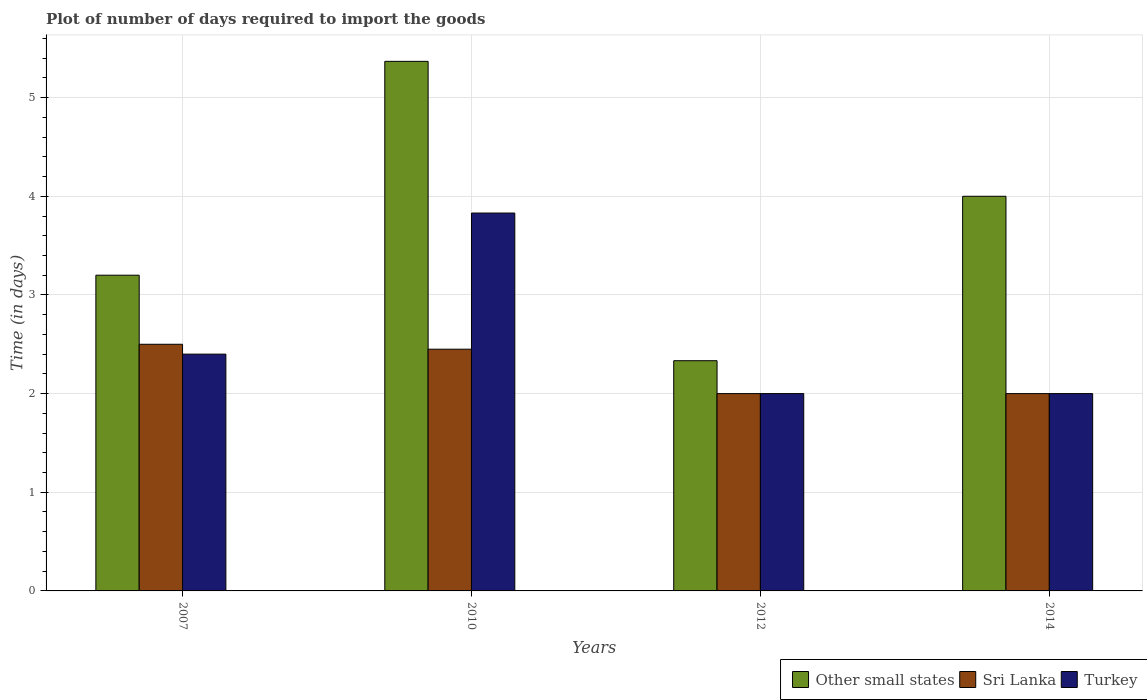How many different coloured bars are there?
Provide a succinct answer. 3. Are the number of bars per tick equal to the number of legend labels?
Give a very brief answer. Yes. How many bars are there on the 3rd tick from the left?
Provide a succinct answer. 3. How many bars are there on the 2nd tick from the right?
Offer a very short reply. 3. What is the label of the 3rd group of bars from the left?
Provide a succinct answer. 2012. In how many cases, is the number of bars for a given year not equal to the number of legend labels?
Ensure brevity in your answer.  0. Across all years, what is the maximum time required to import goods in Turkey?
Ensure brevity in your answer.  3.83. Across all years, what is the minimum time required to import goods in Sri Lanka?
Your response must be concise. 2. In which year was the time required to import goods in Turkey minimum?
Offer a very short reply. 2012. What is the total time required to import goods in Turkey in the graph?
Provide a succinct answer. 10.23. What is the difference between the time required to import goods in Other small states in 2007 and that in 2014?
Your answer should be compact. -0.8. What is the difference between the time required to import goods in Sri Lanka in 2014 and the time required to import goods in Other small states in 2012?
Your response must be concise. -0.33. What is the average time required to import goods in Turkey per year?
Provide a short and direct response. 2.56. In the year 2012, what is the difference between the time required to import goods in Turkey and time required to import goods in Other small states?
Your answer should be very brief. -0.33. In how many years, is the time required to import goods in Sri Lanka greater than 3 days?
Make the answer very short. 0. What is the ratio of the time required to import goods in Other small states in 2010 to that in 2014?
Offer a very short reply. 1.34. Is the difference between the time required to import goods in Turkey in 2010 and 2012 greater than the difference between the time required to import goods in Other small states in 2010 and 2012?
Your answer should be very brief. No. What is the difference between the highest and the second highest time required to import goods in Sri Lanka?
Your answer should be compact. 0.05. What does the 1st bar from the left in 2010 represents?
Give a very brief answer. Other small states. What does the 1st bar from the right in 2007 represents?
Ensure brevity in your answer.  Turkey. How many bars are there?
Give a very brief answer. 12. Are all the bars in the graph horizontal?
Provide a short and direct response. No. How many years are there in the graph?
Your answer should be compact. 4. Are the values on the major ticks of Y-axis written in scientific E-notation?
Your answer should be very brief. No. Does the graph contain grids?
Your answer should be compact. Yes. Where does the legend appear in the graph?
Keep it short and to the point. Bottom right. What is the title of the graph?
Give a very brief answer. Plot of number of days required to import the goods. Does "Mauritania" appear as one of the legend labels in the graph?
Keep it short and to the point. No. What is the label or title of the Y-axis?
Offer a very short reply. Time (in days). What is the Time (in days) in Sri Lanka in 2007?
Provide a succinct answer. 2.5. What is the Time (in days) in Other small states in 2010?
Provide a succinct answer. 5.37. What is the Time (in days) in Sri Lanka in 2010?
Give a very brief answer. 2.45. What is the Time (in days) of Turkey in 2010?
Offer a terse response. 3.83. What is the Time (in days) in Other small states in 2012?
Your answer should be compact. 2.33. What is the Time (in days) of Sri Lanka in 2012?
Make the answer very short. 2. What is the Time (in days) of Turkey in 2012?
Offer a terse response. 2. What is the Time (in days) of Sri Lanka in 2014?
Make the answer very short. 2. Across all years, what is the maximum Time (in days) of Other small states?
Your response must be concise. 5.37. Across all years, what is the maximum Time (in days) in Sri Lanka?
Provide a short and direct response. 2.5. Across all years, what is the maximum Time (in days) of Turkey?
Offer a very short reply. 3.83. Across all years, what is the minimum Time (in days) of Other small states?
Keep it short and to the point. 2.33. Across all years, what is the minimum Time (in days) in Turkey?
Offer a terse response. 2. What is the total Time (in days) of Other small states in the graph?
Offer a very short reply. 14.9. What is the total Time (in days) of Sri Lanka in the graph?
Ensure brevity in your answer.  8.95. What is the total Time (in days) in Turkey in the graph?
Provide a succinct answer. 10.23. What is the difference between the Time (in days) in Other small states in 2007 and that in 2010?
Offer a very short reply. -2.17. What is the difference between the Time (in days) in Turkey in 2007 and that in 2010?
Give a very brief answer. -1.43. What is the difference between the Time (in days) in Other small states in 2007 and that in 2012?
Provide a succinct answer. 0.87. What is the difference between the Time (in days) in Sri Lanka in 2007 and that in 2012?
Your answer should be compact. 0.5. What is the difference between the Time (in days) of Turkey in 2007 and that in 2012?
Ensure brevity in your answer.  0.4. What is the difference between the Time (in days) in Other small states in 2007 and that in 2014?
Offer a terse response. -0.8. What is the difference between the Time (in days) in Sri Lanka in 2007 and that in 2014?
Your answer should be compact. 0.5. What is the difference between the Time (in days) of Turkey in 2007 and that in 2014?
Your answer should be compact. 0.4. What is the difference between the Time (in days) in Other small states in 2010 and that in 2012?
Give a very brief answer. 3.03. What is the difference between the Time (in days) of Sri Lanka in 2010 and that in 2012?
Make the answer very short. 0.45. What is the difference between the Time (in days) in Turkey in 2010 and that in 2012?
Your response must be concise. 1.83. What is the difference between the Time (in days) in Other small states in 2010 and that in 2014?
Give a very brief answer. 1.37. What is the difference between the Time (in days) of Sri Lanka in 2010 and that in 2014?
Your answer should be compact. 0.45. What is the difference between the Time (in days) of Turkey in 2010 and that in 2014?
Make the answer very short. 1.83. What is the difference between the Time (in days) in Other small states in 2012 and that in 2014?
Your answer should be compact. -1.67. What is the difference between the Time (in days) of Sri Lanka in 2012 and that in 2014?
Your response must be concise. 0. What is the difference between the Time (in days) of Other small states in 2007 and the Time (in days) of Turkey in 2010?
Offer a terse response. -0.63. What is the difference between the Time (in days) of Sri Lanka in 2007 and the Time (in days) of Turkey in 2010?
Your answer should be compact. -1.33. What is the difference between the Time (in days) of Other small states in 2007 and the Time (in days) of Sri Lanka in 2012?
Your response must be concise. 1.2. What is the difference between the Time (in days) in Sri Lanka in 2007 and the Time (in days) in Turkey in 2012?
Keep it short and to the point. 0.5. What is the difference between the Time (in days) of Other small states in 2007 and the Time (in days) of Sri Lanka in 2014?
Your response must be concise. 1.2. What is the difference between the Time (in days) of Sri Lanka in 2007 and the Time (in days) of Turkey in 2014?
Your response must be concise. 0.5. What is the difference between the Time (in days) of Other small states in 2010 and the Time (in days) of Sri Lanka in 2012?
Make the answer very short. 3.37. What is the difference between the Time (in days) of Other small states in 2010 and the Time (in days) of Turkey in 2012?
Make the answer very short. 3.37. What is the difference between the Time (in days) in Sri Lanka in 2010 and the Time (in days) in Turkey in 2012?
Provide a succinct answer. 0.45. What is the difference between the Time (in days) in Other small states in 2010 and the Time (in days) in Sri Lanka in 2014?
Give a very brief answer. 3.37. What is the difference between the Time (in days) of Other small states in 2010 and the Time (in days) of Turkey in 2014?
Provide a succinct answer. 3.37. What is the difference between the Time (in days) of Sri Lanka in 2010 and the Time (in days) of Turkey in 2014?
Your answer should be very brief. 0.45. What is the average Time (in days) in Other small states per year?
Ensure brevity in your answer.  3.73. What is the average Time (in days) of Sri Lanka per year?
Your response must be concise. 2.24. What is the average Time (in days) of Turkey per year?
Provide a succinct answer. 2.56. In the year 2007, what is the difference between the Time (in days) of Sri Lanka and Time (in days) of Turkey?
Your answer should be compact. 0.1. In the year 2010, what is the difference between the Time (in days) in Other small states and Time (in days) in Sri Lanka?
Your answer should be very brief. 2.92. In the year 2010, what is the difference between the Time (in days) of Other small states and Time (in days) of Turkey?
Provide a short and direct response. 1.54. In the year 2010, what is the difference between the Time (in days) in Sri Lanka and Time (in days) in Turkey?
Your answer should be very brief. -1.38. In the year 2012, what is the difference between the Time (in days) of Other small states and Time (in days) of Sri Lanka?
Your answer should be compact. 0.33. In the year 2014, what is the difference between the Time (in days) in Other small states and Time (in days) in Sri Lanka?
Your answer should be very brief. 2. In the year 2014, what is the difference between the Time (in days) of Other small states and Time (in days) of Turkey?
Provide a succinct answer. 2. In the year 2014, what is the difference between the Time (in days) of Sri Lanka and Time (in days) of Turkey?
Ensure brevity in your answer.  0. What is the ratio of the Time (in days) of Other small states in 2007 to that in 2010?
Offer a terse response. 0.6. What is the ratio of the Time (in days) in Sri Lanka in 2007 to that in 2010?
Provide a succinct answer. 1.02. What is the ratio of the Time (in days) in Turkey in 2007 to that in 2010?
Ensure brevity in your answer.  0.63. What is the ratio of the Time (in days) of Other small states in 2007 to that in 2012?
Provide a short and direct response. 1.37. What is the ratio of the Time (in days) of Sri Lanka in 2007 to that in 2012?
Make the answer very short. 1.25. What is the ratio of the Time (in days) in Turkey in 2007 to that in 2012?
Your answer should be very brief. 1.2. What is the ratio of the Time (in days) of Turkey in 2007 to that in 2014?
Offer a terse response. 1.2. What is the ratio of the Time (in days) in Other small states in 2010 to that in 2012?
Give a very brief answer. 2.3. What is the ratio of the Time (in days) of Sri Lanka in 2010 to that in 2012?
Provide a short and direct response. 1.23. What is the ratio of the Time (in days) in Turkey in 2010 to that in 2012?
Offer a terse response. 1.92. What is the ratio of the Time (in days) in Other small states in 2010 to that in 2014?
Your answer should be very brief. 1.34. What is the ratio of the Time (in days) of Sri Lanka in 2010 to that in 2014?
Give a very brief answer. 1.23. What is the ratio of the Time (in days) of Turkey in 2010 to that in 2014?
Make the answer very short. 1.92. What is the ratio of the Time (in days) in Other small states in 2012 to that in 2014?
Offer a terse response. 0.58. What is the difference between the highest and the second highest Time (in days) in Other small states?
Ensure brevity in your answer.  1.37. What is the difference between the highest and the second highest Time (in days) of Turkey?
Give a very brief answer. 1.43. What is the difference between the highest and the lowest Time (in days) in Other small states?
Make the answer very short. 3.03. What is the difference between the highest and the lowest Time (in days) in Sri Lanka?
Your answer should be compact. 0.5. What is the difference between the highest and the lowest Time (in days) of Turkey?
Offer a terse response. 1.83. 